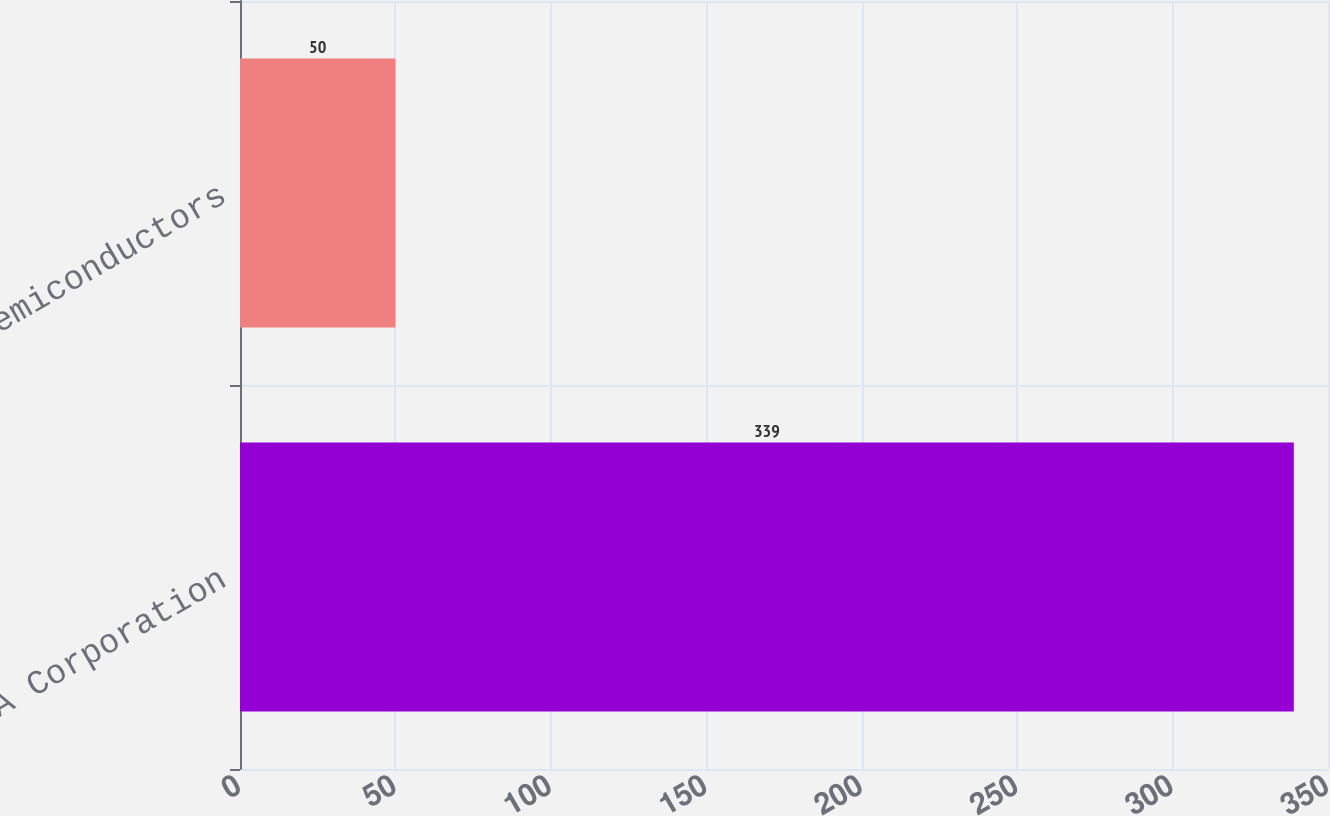<chart> <loc_0><loc_0><loc_500><loc_500><bar_chart><fcel>NVIDIA Corporation<fcel>S&P Semiconductors<nl><fcel>339<fcel>50<nl></chart> 